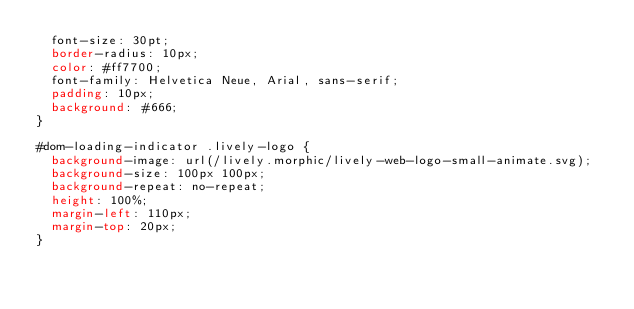<code> <loc_0><loc_0><loc_500><loc_500><_CSS_>  font-size: 30pt;
  border-radius: 10px;
  color: #ff7700;
  font-family: Helvetica Neue, Arial, sans-serif;
  padding: 10px;
  background: #666;
}

#dom-loading-indicator .lively-logo {
  background-image: url(/lively.morphic/lively-web-logo-small-animate.svg);
  background-size: 100px 100px;
  background-repeat: no-repeat;
  height: 100%;
  margin-left: 110px;
  margin-top: 20px;
}
</code> 